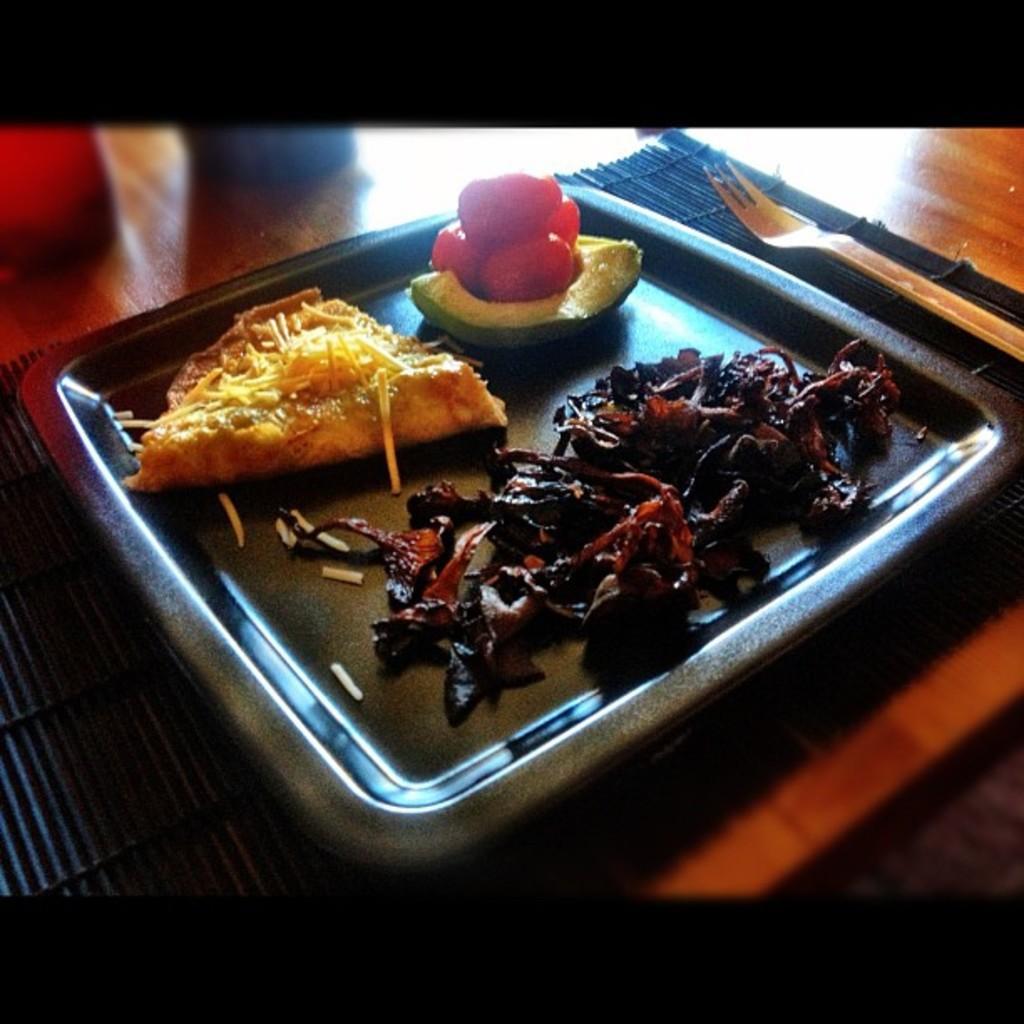Please provide a concise description of this image. In the center of the image we can see a plate containing food, a table mat and a fork placed on the table. 